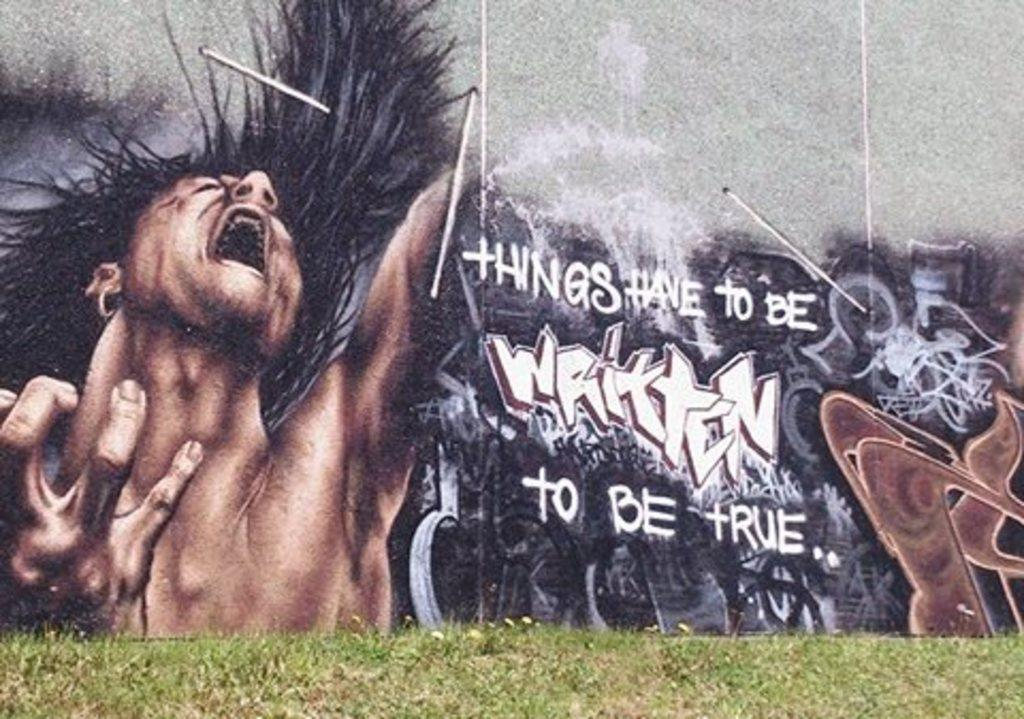<image>
Present a compact description of the photo's key features. The graffiti says only written things can be true. 